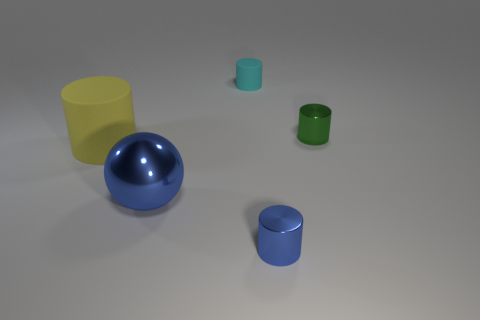Is the shape of the small cyan rubber thing the same as the small green object?
Your answer should be very brief. Yes. What number of things are gray cylinders or blue shiny objects that are to the left of the tiny cyan thing?
Provide a succinct answer. 1. How many tiny cyan things are there?
Ensure brevity in your answer.  1. Are there any gray cylinders of the same size as the cyan rubber object?
Offer a terse response. No. Are there fewer big blue shiny spheres behind the green metallic cylinder than small metallic things?
Make the answer very short. Yes. Is the size of the blue metallic sphere the same as the green thing?
Make the answer very short. No. What is the size of the blue thing that is made of the same material as the blue cylinder?
Provide a short and direct response. Large. What number of tiny metallic objects are the same color as the big rubber thing?
Give a very brief answer. 0. Is the number of big blue shiny things that are in front of the big sphere less than the number of blue cylinders behind the tiny blue thing?
Make the answer very short. No. There is a thing in front of the blue shiny ball; does it have the same shape as the yellow object?
Offer a terse response. Yes. 